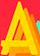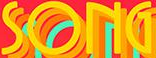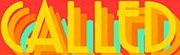What text appears in these images from left to right, separated by a semicolon? A; SONG; CALLED 